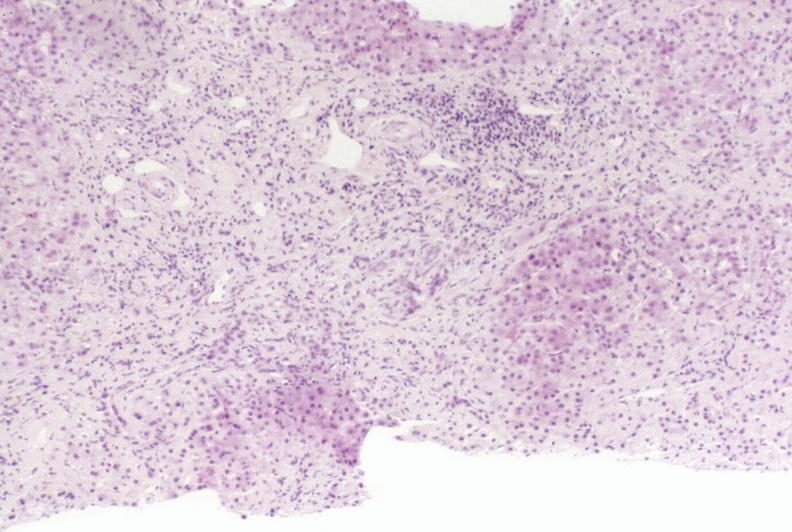what is present?
Answer the question using a single word or phrase. Liver 